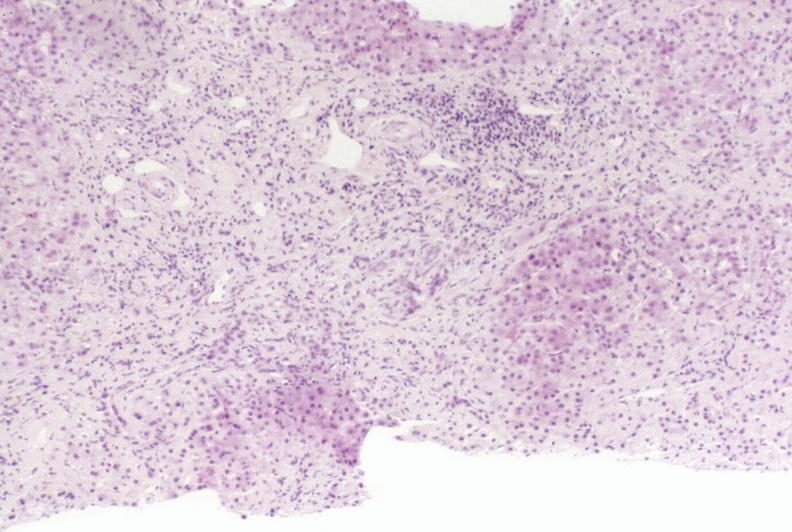what is present?
Answer the question using a single word or phrase. Liver 